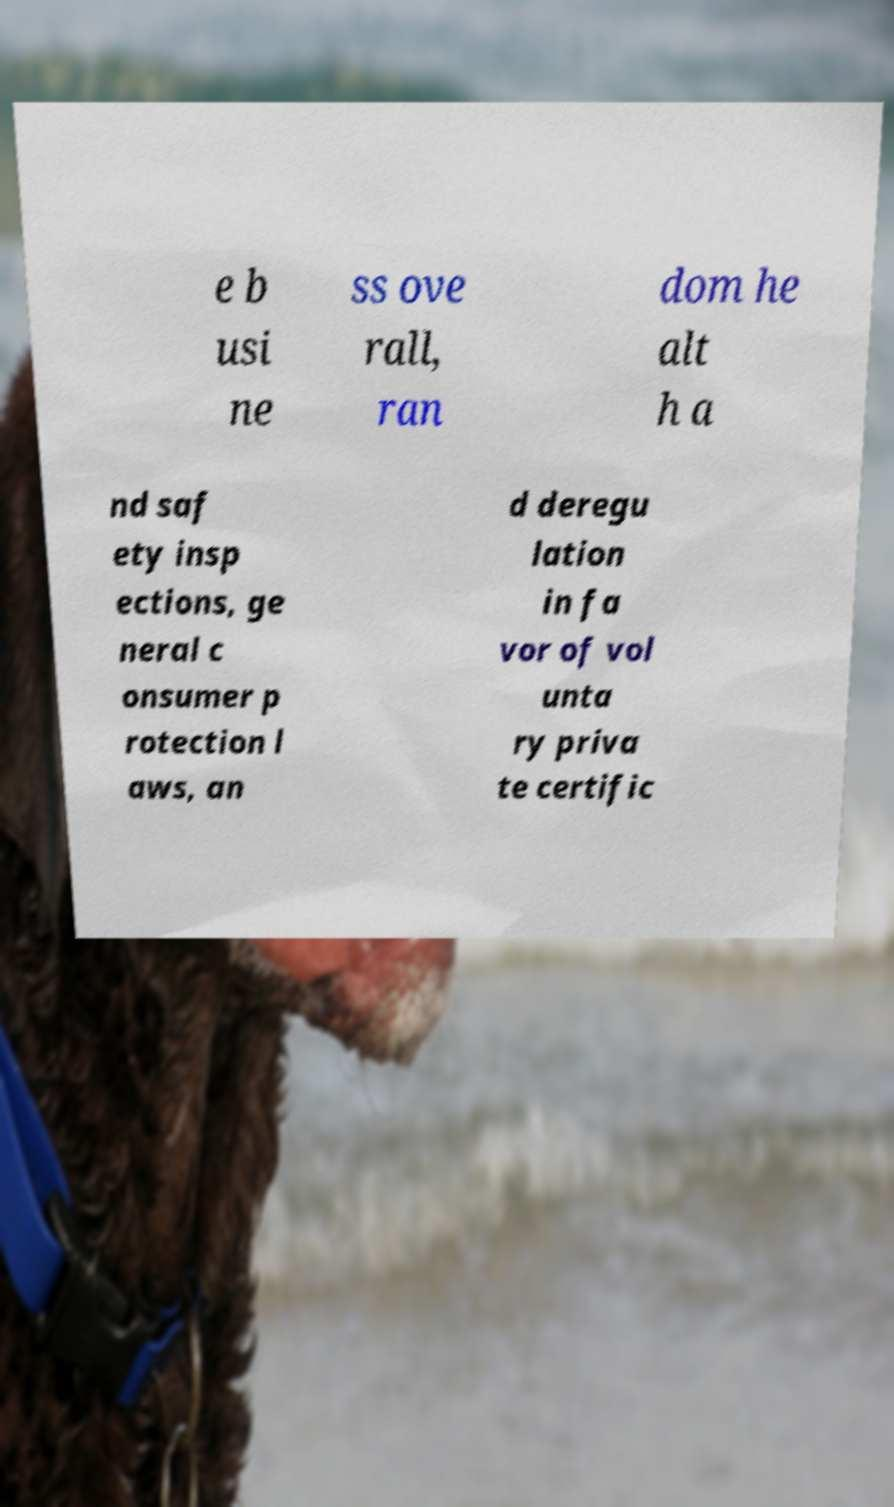I need the written content from this picture converted into text. Can you do that? e b usi ne ss ove rall, ran dom he alt h a nd saf ety insp ections, ge neral c onsumer p rotection l aws, an d deregu lation in fa vor of vol unta ry priva te certific 